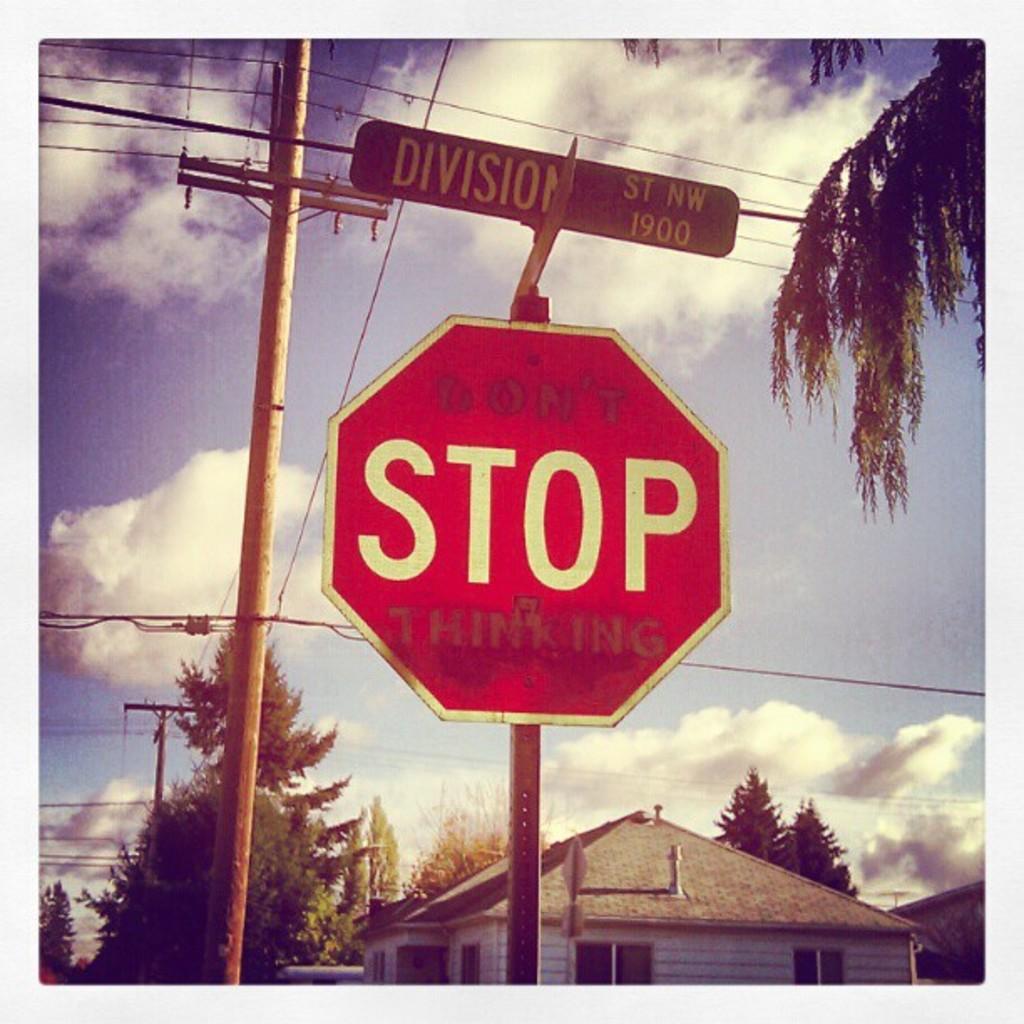What does the sign tell you to do?
Your answer should be very brief. Stop. 